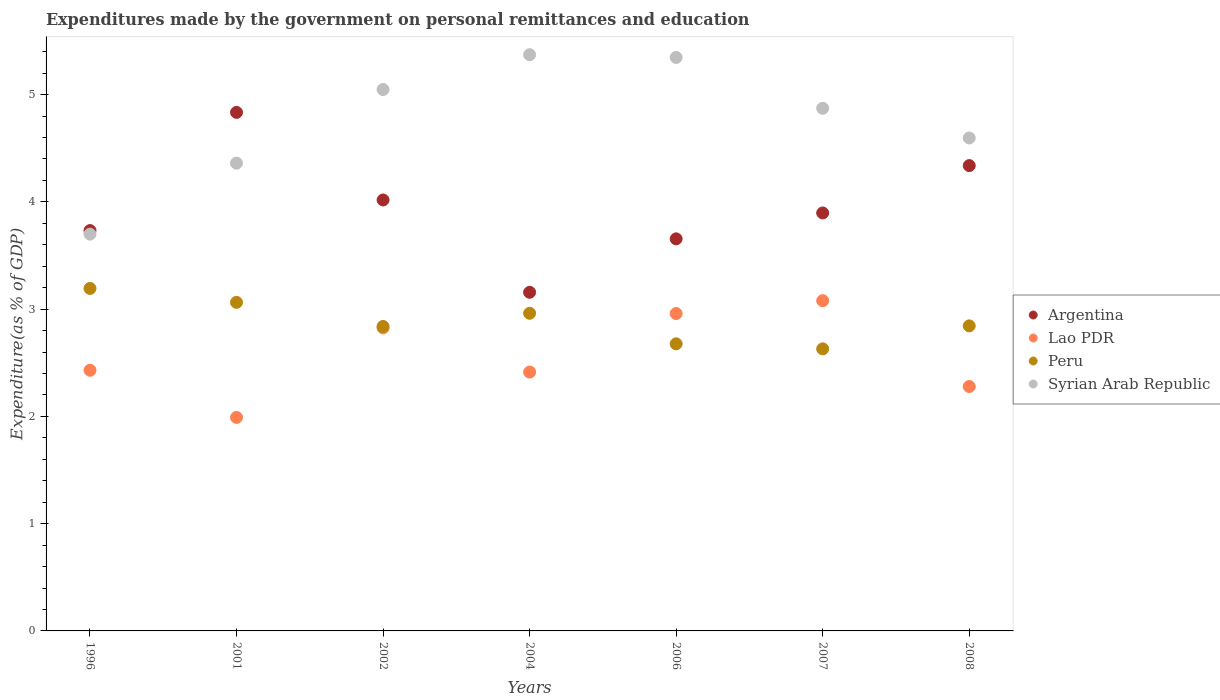What is the expenditures made by the government on personal remittances and education in Peru in 2008?
Your answer should be compact. 2.84. Across all years, what is the maximum expenditures made by the government on personal remittances and education in Syrian Arab Republic?
Provide a succinct answer. 5.37. Across all years, what is the minimum expenditures made by the government on personal remittances and education in Syrian Arab Republic?
Your answer should be compact. 3.7. In which year was the expenditures made by the government on personal remittances and education in Lao PDR maximum?
Provide a succinct answer. 2007. In which year was the expenditures made by the government on personal remittances and education in Argentina minimum?
Offer a very short reply. 2004. What is the total expenditures made by the government on personal remittances and education in Lao PDR in the graph?
Offer a very short reply. 17.97. What is the difference between the expenditures made by the government on personal remittances and education in Lao PDR in 1996 and that in 2008?
Your answer should be compact. 0.15. What is the difference between the expenditures made by the government on personal remittances and education in Peru in 2006 and the expenditures made by the government on personal remittances and education in Argentina in 2002?
Ensure brevity in your answer.  -1.34. What is the average expenditures made by the government on personal remittances and education in Lao PDR per year?
Make the answer very short. 2.57. In the year 2002, what is the difference between the expenditures made by the government on personal remittances and education in Peru and expenditures made by the government on personal remittances and education in Argentina?
Offer a very short reply. -1.18. What is the ratio of the expenditures made by the government on personal remittances and education in Peru in 1996 to that in 2001?
Give a very brief answer. 1.04. Is the difference between the expenditures made by the government on personal remittances and education in Peru in 2001 and 2002 greater than the difference between the expenditures made by the government on personal remittances and education in Argentina in 2001 and 2002?
Provide a short and direct response. No. What is the difference between the highest and the second highest expenditures made by the government on personal remittances and education in Peru?
Your answer should be compact. 0.13. What is the difference between the highest and the lowest expenditures made by the government on personal remittances and education in Syrian Arab Republic?
Your answer should be very brief. 1.67. Is the sum of the expenditures made by the government on personal remittances and education in Syrian Arab Republic in 2001 and 2008 greater than the maximum expenditures made by the government on personal remittances and education in Peru across all years?
Your answer should be very brief. Yes. Is it the case that in every year, the sum of the expenditures made by the government on personal remittances and education in Peru and expenditures made by the government on personal remittances and education in Argentina  is greater than the sum of expenditures made by the government on personal remittances and education in Lao PDR and expenditures made by the government on personal remittances and education in Syrian Arab Republic?
Provide a succinct answer. No. Is the expenditures made by the government on personal remittances and education in Syrian Arab Republic strictly greater than the expenditures made by the government on personal remittances and education in Argentina over the years?
Your answer should be very brief. No. How many years are there in the graph?
Your answer should be compact. 7. What is the difference between two consecutive major ticks on the Y-axis?
Your answer should be compact. 1. Does the graph contain any zero values?
Make the answer very short. No. Where does the legend appear in the graph?
Your answer should be compact. Center right. What is the title of the graph?
Provide a succinct answer. Expenditures made by the government on personal remittances and education. What is the label or title of the X-axis?
Your answer should be compact. Years. What is the label or title of the Y-axis?
Give a very brief answer. Expenditure(as % of GDP). What is the Expenditure(as % of GDP) in Argentina in 1996?
Your response must be concise. 3.73. What is the Expenditure(as % of GDP) in Lao PDR in 1996?
Your answer should be very brief. 2.43. What is the Expenditure(as % of GDP) of Peru in 1996?
Keep it short and to the point. 3.19. What is the Expenditure(as % of GDP) in Syrian Arab Republic in 1996?
Provide a short and direct response. 3.7. What is the Expenditure(as % of GDP) of Argentina in 2001?
Provide a succinct answer. 4.83. What is the Expenditure(as % of GDP) in Lao PDR in 2001?
Provide a short and direct response. 1.99. What is the Expenditure(as % of GDP) of Peru in 2001?
Your answer should be very brief. 3.06. What is the Expenditure(as % of GDP) in Syrian Arab Republic in 2001?
Make the answer very short. 4.36. What is the Expenditure(as % of GDP) in Argentina in 2002?
Keep it short and to the point. 4.02. What is the Expenditure(as % of GDP) of Lao PDR in 2002?
Offer a very short reply. 2.83. What is the Expenditure(as % of GDP) in Peru in 2002?
Make the answer very short. 2.84. What is the Expenditure(as % of GDP) in Syrian Arab Republic in 2002?
Offer a terse response. 5.05. What is the Expenditure(as % of GDP) in Argentina in 2004?
Provide a succinct answer. 3.16. What is the Expenditure(as % of GDP) of Lao PDR in 2004?
Your response must be concise. 2.41. What is the Expenditure(as % of GDP) in Peru in 2004?
Provide a short and direct response. 2.96. What is the Expenditure(as % of GDP) of Syrian Arab Republic in 2004?
Keep it short and to the point. 5.37. What is the Expenditure(as % of GDP) in Argentina in 2006?
Provide a short and direct response. 3.65. What is the Expenditure(as % of GDP) of Lao PDR in 2006?
Keep it short and to the point. 2.96. What is the Expenditure(as % of GDP) in Peru in 2006?
Your answer should be compact. 2.68. What is the Expenditure(as % of GDP) in Syrian Arab Republic in 2006?
Give a very brief answer. 5.35. What is the Expenditure(as % of GDP) of Argentina in 2007?
Keep it short and to the point. 3.9. What is the Expenditure(as % of GDP) of Lao PDR in 2007?
Keep it short and to the point. 3.08. What is the Expenditure(as % of GDP) of Peru in 2007?
Your answer should be compact. 2.63. What is the Expenditure(as % of GDP) in Syrian Arab Republic in 2007?
Your answer should be compact. 4.87. What is the Expenditure(as % of GDP) in Argentina in 2008?
Your answer should be very brief. 4.34. What is the Expenditure(as % of GDP) in Lao PDR in 2008?
Offer a very short reply. 2.28. What is the Expenditure(as % of GDP) in Peru in 2008?
Offer a terse response. 2.84. What is the Expenditure(as % of GDP) in Syrian Arab Republic in 2008?
Ensure brevity in your answer.  4.6. Across all years, what is the maximum Expenditure(as % of GDP) in Argentina?
Provide a short and direct response. 4.83. Across all years, what is the maximum Expenditure(as % of GDP) in Lao PDR?
Offer a terse response. 3.08. Across all years, what is the maximum Expenditure(as % of GDP) of Peru?
Provide a short and direct response. 3.19. Across all years, what is the maximum Expenditure(as % of GDP) in Syrian Arab Republic?
Your response must be concise. 5.37. Across all years, what is the minimum Expenditure(as % of GDP) of Argentina?
Ensure brevity in your answer.  3.16. Across all years, what is the minimum Expenditure(as % of GDP) of Lao PDR?
Your answer should be very brief. 1.99. Across all years, what is the minimum Expenditure(as % of GDP) in Peru?
Your response must be concise. 2.63. Across all years, what is the minimum Expenditure(as % of GDP) of Syrian Arab Republic?
Ensure brevity in your answer.  3.7. What is the total Expenditure(as % of GDP) of Argentina in the graph?
Your answer should be very brief. 27.63. What is the total Expenditure(as % of GDP) of Lao PDR in the graph?
Your response must be concise. 17.97. What is the total Expenditure(as % of GDP) in Peru in the graph?
Your answer should be very brief. 20.2. What is the total Expenditure(as % of GDP) of Syrian Arab Republic in the graph?
Ensure brevity in your answer.  33.29. What is the difference between the Expenditure(as % of GDP) in Argentina in 1996 and that in 2001?
Offer a very short reply. -1.1. What is the difference between the Expenditure(as % of GDP) of Lao PDR in 1996 and that in 2001?
Ensure brevity in your answer.  0.44. What is the difference between the Expenditure(as % of GDP) of Peru in 1996 and that in 2001?
Your answer should be compact. 0.13. What is the difference between the Expenditure(as % of GDP) in Syrian Arab Republic in 1996 and that in 2001?
Provide a succinct answer. -0.66. What is the difference between the Expenditure(as % of GDP) of Argentina in 1996 and that in 2002?
Keep it short and to the point. -0.29. What is the difference between the Expenditure(as % of GDP) of Lao PDR in 1996 and that in 2002?
Provide a succinct answer. -0.4. What is the difference between the Expenditure(as % of GDP) of Peru in 1996 and that in 2002?
Ensure brevity in your answer.  0.35. What is the difference between the Expenditure(as % of GDP) in Syrian Arab Republic in 1996 and that in 2002?
Your answer should be very brief. -1.35. What is the difference between the Expenditure(as % of GDP) in Argentina in 1996 and that in 2004?
Your answer should be very brief. 0.58. What is the difference between the Expenditure(as % of GDP) in Lao PDR in 1996 and that in 2004?
Provide a succinct answer. 0.02. What is the difference between the Expenditure(as % of GDP) of Peru in 1996 and that in 2004?
Your response must be concise. 0.23. What is the difference between the Expenditure(as % of GDP) of Syrian Arab Republic in 1996 and that in 2004?
Your response must be concise. -1.67. What is the difference between the Expenditure(as % of GDP) in Argentina in 1996 and that in 2006?
Provide a succinct answer. 0.08. What is the difference between the Expenditure(as % of GDP) of Lao PDR in 1996 and that in 2006?
Offer a terse response. -0.53. What is the difference between the Expenditure(as % of GDP) of Peru in 1996 and that in 2006?
Provide a short and direct response. 0.52. What is the difference between the Expenditure(as % of GDP) in Syrian Arab Republic in 1996 and that in 2006?
Ensure brevity in your answer.  -1.65. What is the difference between the Expenditure(as % of GDP) in Argentina in 1996 and that in 2007?
Make the answer very short. -0.16. What is the difference between the Expenditure(as % of GDP) of Lao PDR in 1996 and that in 2007?
Provide a succinct answer. -0.65. What is the difference between the Expenditure(as % of GDP) of Peru in 1996 and that in 2007?
Make the answer very short. 0.56. What is the difference between the Expenditure(as % of GDP) in Syrian Arab Republic in 1996 and that in 2007?
Keep it short and to the point. -1.17. What is the difference between the Expenditure(as % of GDP) in Argentina in 1996 and that in 2008?
Provide a succinct answer. -0.61. What is the difference between the Expenditure(as % of GDP) of Lao PDR in 1996 and that in 2008?
Make the answer very short. 0.15. What is the difference between the Expenditure(as % of GDP) of Peru in 1996 and that in 2008?
Offer a terse response. 0.35. What is the difference between the Expenditure(as % of GDP) in Syrian Arab Republic in 1996 and that in 2008?
Provide a short and direct response. -0.9. What is the difference between the Expenditure(as % of GDP) of Argentina in 2001 and that in 2002?
Your answer should be compact. 0.82. What is the difference between the Expenditure(as % of GDP) of Lao PDR in 2001 and that in 2002?
Offer a very short reply. -0.83. What is the difference between the Expenditure(as % of GDP) of Peru in 2001 and that in 2002?
Provide a short and direct response. 0.22. What is the difference between the Expenditure(as % of GDP) in Syrian Arab Republic in 2001 and that in 2002?
Offer a very short reply. -0.69. What is the difference between the Expenditure(as % of GDP) of Argentina in 2001 and that in 2004?
Provide a succinct answer. 1.68. What is the difference between the Expenditure(as % of GDP) of Lao PDR in 2001 and that in 2004?
Offer a very short reply. -0.42. What is the difference between the Expenditure(as % of GDP) in Peru in 2001 and that in 2004?
Ensure brevity in your answer.  0.1. What is the difference between the Expenditure(as % of GDP) in Syrian Arab Republic in 2001 and that in 2004?
Give a very brief answer. -1.01. What is the difference between the Expenditure(as % of GDP) in Argentina in 2001 and that in 2006?
Your response must be concise. 1.18. What is the difference between the Expenditure(as % of GDP) of Lao PDR in 2001 and that in 2006?
Offer a terse response. -0.97. What is the difference between the Expenditure(as % of GDP) of Peru in 2001 and that in 2006?
Offer a very short reply. 0.39. What is the difference between the Expenditure(as % of GDP) in Syrian Arab Republic in 2001 and that in 2006?
Your answer should be very brief. -0.99. What is the difference between the Expenditure(as % of GDP) of Argentina in 2001 and that in 2007?
Provide a succinct answer. 0.94. What is the difference between the Expenditure(as % of GDP) in Lao PDR in 2001 and that in 2007?
Offer a very short reply. -1.09. What is the difference between the Expenditure(as % of GDP) of Peru in 2001 and that in 2007?
Your response must be concise. 0.43. What is the difference between the Expenditure(as % of GDP) of Syrian Arab Republic in 2001 and that in 2007?
Your answer should be very brief. -0.51. What is the difference between the Expenditure(as % of GDP) in Argentina in 2001 and that in 2008?
Offer a terse response. 0.5. What is the difference between the Expenditure(as % of GDP) of Lao PDR in 2001 and that in 2008?
Your response must be concise. -0.29. What is the difference between the Expenditure(as % of GDP) in Peru in 2001 and that in 2008?
Make the answer very short. 0.22. What is the difference between the Expenditure(as % of GDP) in Syrian Arab Republic in 2001 and that in 2008?
Provide a short and direct response. -0.23. What is the difference between the Expenditure(as % of GDP) in Argentina in 2002 and that in 2004?
Provide a short and direct response. 0.86. What is the difference between the Expenditure(as % of GDP) of Lao PDR in 2002 and that in 2004?
Offer a terse response. 0.41. What is the difference between the Expenditure(as % of GDP) in Peru in 2002 and that in 2004?
Make the answer very short. -0.12. What is the difference between the Expenditure(as % of GDP) of Syrian Arab Republic in 2002 and that in 2004?
Make the answer very short. -0.32. What is the difference between the Expenditure(as % of GDP) of Argentina in 2002 and that in 2006?
Your answer should be compact. 0.36. What is the difference between the Expenditure(as % of GDP) of Lao PDR in 2002 and that in 2006?
Ensure brevity in your answer.  -0.13. What is the difference between the Expenditure(as % of GDP) in Peru in 2002 and that in 2006?
Provide a short and direct response. 0.16. What is the difference between the Expenditure(as % of GDP) in Syrian Arab Republic in 2002 and that in 2006?
Give a very brief answer. -0.3. What is the difference between the Expenditure(as % of GDP) in Argentina in 2002 and that in 2007?
Keep it short and to the point. 0.12. What is the difference between the Expenditure(as % of GDP) in Lao PDR in 2002 and that in 2007?
Provide a succinct answer. -0.25. What is the difference between the Expenditure(as % of GDP) in Peru in 2002 and that in 2007?
Provide a succinct answer. 0.21. What is the difference between the Expenditure(as % of GDP) of Syrian Arab Republic in 2002 and that in 2007?
Ensure brevity in your answer.  0.17. What is the difference between the Expenditure(as % of GDP) in Argentina in 2002 and that in 2008?
Your answer should be compact. -0.32. What is the difference between the Expenditure(as % of GDP) of Lao PDR in 2002 and that in 2008?
Make the answer very short. 0.55. What is the difference between the Expenditure(as % of GDP) in Peru in 2002 and that in 2008?
Keep it short and to the point. -0.01. What is the difference between the Expenditure(as % of GDP) of Syrian Arab Republic in 2002 and that in 2008?
Keep it short and to the point. 0.45. What is the difference between the Expenditure(as % of GDP) of Argentina in 2004 and that in 2006?
Provide a short and direct response. -0.5. What is the difference between the Expenditure(as % of GDP) in Lao PDR in 2004 and that in 2006?
Provide a short and direct response. -0.55. What is the difference between the Expenditure(as % of GDP) in Peru in 2004 and that in 2006?
Provide a succinct answer. 0.28. What is the difference between the Expenditure(as % of GDP) in Syrian Arab Republic in 2004 and that in 2006?
Keep it short and to the point. 0.03. What is the difference between the Expenditure(as % of GDP) of Argentina in 2004 and that in 2007?
Keep it short and to the point. -0.74. What is the difference between the Expenditure(as % of GDP) of Lao PDR in 2004 and that in 2007?
Your answer should be very brief. -0.67. What is the difference between the Expenditure(as % of GDP) in Peru in 2004 and that in 2007?
Your answer should be very brief. 0.33. What is the difference between the Expenditure(as % of GDP) of Syrian Arab Republic in 2004 and that in 2007?
Offer a terse response. 0.5. What is the difference between the Expenditure(as % of GDP) in Argentina in 2004 and that in 2008?
Make the answer very short. -1.18. What is the difference between the Expenditure(as % of GDP) in Lao PDR in 2004 and that in 2008?
Provide a succinct answer. 0.13. What is the difference between the Expenditure(as % of GDP) in Peru in 2004 and that in 2008?
Make the answer very short. 0.12. What is the difference between the Expenditure(as % of GDP) in Syrian Arab Republic in 2004 and that in 2008?
Ensure brevity in your answer.  0.78. What is the difference between the Expenditure(as % of GDP) of Argentina in 2006 and that in 2007?
Your answer should be very brief. -0.24. What is the difference between the Expenditure(as % of GDP) of Lao PDR in 2006 and that in 2007?
Give a very brief answer. -0.12. What is the difference between the Expenditure(as % of GDP) of Peru in 2006 and that in 2007?
Keep it short and to the point. 0.05. What is the difference between the Expenditure(as % of GDP) in Syrian Arab Republic in 2006 and that in 2007?
Offer a very short reply. 0.47. What is the difference between the Expenditure(as % of GDP) in Argentina in 2006 and that in 2008?
Your answer should be very brief. -0.68. What is the difference between the Expenditure(as % of GDP) in Lao PDR in 2006 and that in 2008?
Your answer should be very brief. 0.68. What is the difference between the Expenditure(as % of GDP) in Peru in 2006 and that in 2008?
Offer a terse response. -0.17. What is the difference between the Expenditure(as % of GDP) of Syrian Arab Republic in 2006 and that in 2008?
Your answer should be very brief. 0.75. What is the difference between the Expenditure(as % of GDP) in Argentina in 2007 and that in 2008?
Your answer should be very brief. -0.44. What is the difference between the Expenditure(as % of GDP) of Lao PDR in 2007 and that in 2008?
Ensure brevity in your answer.  0.8. What is the difference between the Expenditure(as % of GDP) of Peru in 2007 and that in 2008?
Offer a terse response. -0.21. What is the difference between the Expenditure(as % of GDP) in Syrian Arab Republic in 2007 and that in 2008?
Provide a succinct answer. 0.28. What is the difference between the Expenditure(as % of GDP) of Argentina in 1996 and the Expenditure(as % of GDP) of Lao PDR in 2001?
Keep it short and to the point. 1.74. What is the difference between the Expenditure(as % of GDP) in Argentina in 1996 and the Expenditure(as % of GDP) in Peru in 2001?
Keep it short and to the point. 0.67. What is the difference between the Expenditure(as % of GDP) of Argentina in 1996 and the Expenditure(as % of GDP) of Syrian Arab Republic in 2001?
Your answer should be compact. -0.63. What is the difference between the Expenditure(as % of GDP) in Lao PDR in 1996 and the Expenditure(as % of GDP) in Peru in 2001?
Your answer should be compact. -0.63. What is the difference between the Expenditure(as % of GDP) of Lao PDR in 1996 and the Expenditure(as % of GDP) of Syrian Arab Republic in 2001?
Your answer should be very brief. -1.93. What is the difference between the Expenditure(as % of GDP) in Peru in 1996 and the Expenditure(as % of GDP) in Syrian Arab Republic in 2001?
Ensure brevity in your answer.  -1.17. What is the difference between the Expenditure(as % of GDP) in Argentina in 1996 and the Expenditure(as % of GDP) in Lao PDR in 2002?
Offer a very short reply. 0.91. What is the difference between the Expenditure(as % of GDP) of Argentina in 1996 and the Expenditure(as % of GDP) of Peru in 2002?
Provide a succinct answer. 0.89. What is the difference between the Expenditure(as % of GDP) of Argentina in 1996 and the Expenditure(as % of GDP) of Syrian Arab Republic in 2002?
Your answer should be compact. -1.31. What is the difference between the Expenditure(as % of GDP) of Lao PDR in 1996 and the Expenditure(as % of GDP) of Peru in 2002?
Ensure brevity in your answer.  -0.41. What is the difference between the Expenditure(as % of GDP) of Lao PDR in 1996 and the Expenditure(as % of GDP) of Syrian Arab Republic in 2002?
Ensure brevity in your answer.  -2.62. What is the difference between the Expenditure(as % of GDP) in Peru in 1996 and the Expenditure(as % of GDP) in Syrian Arab Republic in 2002?
Offer a terse response. -1.85. What is the difference between the Expenditure(as % of GDP) in Argentina in 1996 and the Expenditure(as % of GDP) in Lao PDR in 2004?
Keep it short and to the point. 1.32. What is the difference between the Expenditure(as % of GDP) in Argentina in 1996 and the Expenditure(as % of GDP) in Peru in 2004?
Offer a very short reply. 0.77. What is the difference between the Expenditure(as % of GDP) in Argentina in 1996 and the Expenditure(as % of GDP) in Syrian Arab Republic in 2004?
Keep it short and to the point. -1.64. What is the difference between the Expenditure(as % of GDP) in Lao PDR in 1996 and the Expenditure(as % of GDP) in Peru in 2004?
Provide a succinct answer. -0.53. What is the difference between the Expenditure(as % of GDP) of Lao PDR in 1996 and the Expenditure(as % of GDP) of Syrian Arab Republic in 2004?
Your response must be concise. -2.94. What is the difference between the Expenditure(as % of GDP) in Peru in 1996 and the Expenditure(as % of GDP) in Syrian Arab Republic in 2004?
Keep it short and to the point. -2.18. What is the difference between the Expenditure(as % of GDP) in Argentina in 1996 and the Expenditure(as % of GDP) in Lao PDR in 2006?
Give a very brief answer. 0.77. What is the difference between the Expenditure(as % of GDP) in Argentina in 1996 and the Expenditure(as % of GDP) in Peru in 2006?
Give a very brief answer. 1.06. What is the difference between the Expenditure(as % of GDP) in Argentina in 1996 and the Expenditure(as % of GDP) in Syrian Arab Republic in 2006?
Provide a succinct answer. -1.61. What is the difference between the Expenditure(as % of GDP) of Lao PDR in 1996 and the Expenditure(as % of GDP) of Peru in 2006?
Your answer should be compact. -0.25. What is the difference between the Expenditure(as % of GDP) of Lao PDR in 1996 and the Expenditure(as % of GDP) of Syrian Arab Republic in 2006?
Provide a short and direct response. -2.92. What is the difference between the Expenditure(as % of GDP) in Peru in 1996 and the Expenditure(as % of GDP) in Syrian Arab Republic in 2006?
Your answer should be compact. -2.15. What is the difference between the Expenditure(as % of GDP) of Argentina in 1996 and the Expenditure(as % of GDP) of Lao PDR in 2007?
Provide a short and direct response. 0.65. What is the difference between the Expenditure(as % of GDP) of Argentina in 1996 and the Expenditure(as % of GDP) of Peru in 2007?
Offer a very short reply. 1.1. What is the difference between the Expenditure(as % of GDP) in Argentina in 1996 and the Expenditure(as % of GDP) in Syrian Arab Republic in 2007?
Make the answer very short. -1.14. What is the difference between the Expenditure(as % of GDP) of Lao PDR in 1996 and the Expenditure(as % of GDP) of Peru in 2007?
Give a very brief answer. -0.2. What is the difference between the Expenditure(as % of GDP) in Lao PDR in 1996 and the Expenditure(as % of GDP) in Syrian Arab Republic in 2007?
Offer a very short reply. -2.44. What is the difference between the Expenditure(as % of GDP) in Peru in 1996 and the Expenditure(as % of GDP) in Syrian Arab Republic in 2007?
Give a very brief answer. -1.68. What is the difference between the Expenditure(as % of GDP) of Argentina in 1996 and the Expenditure(as % of GDP) of Lao PDR in 2008?
Offer a very short reply. 1.45. What is the difference between the Expenditure(as % of GDP) of Argentina in 1996 and the Expenditure(as % of GDP) of Peru in 2008?
Your response must be concise. 0.89. What is the difference between the Expenditure(as % of GDP) in Argentina in 1996 and the Expenditure(as % of GDP) in Syrian Arab Republic in 2008?
Provide a short and direct response. -0.86. What is the difference between the Expenditure(as % of GDP) in Lao PDR in 1996 and the Expenditure(as % of GDP) in Peru in 2008?
Provide a short and direct response. -0.41. What is the difference between the Expenditure(as % of GDP) of Lao PDR in 1996 and the Expenditure(as % of GDP) of Syrian Arab Republic in 2008?
Provide a succinct answer. -2.17. What is the difference between the Expenditure(as % of GDP) of Peru in 1996 and the Expenditure(as % of GDP) of Syrian Arab Republic in 2008?
Make the answer very short. -1.4. What is the difference between the Expenditure(as % of GDP) of Argentina in 2001 and the Expenditure(as % of GDP) of Lao PDR in 2002?
Provide a succinct answer. 2.01. What is the difference between the Expenditure(as % of GDP) of Argentina in 2001 and the Expenditure(as % of GDP) of Peru in 2002?
Your response must be concise. 2. What is the difference between the Expenditure(as % of GDP) of Argentina in 2001 and the Expenditure(as % of GDP) of Syrian Arab Republic in 2002?
Your answer should be compact. -0.21. What is the difference between the Expenditure(as % of GDP) in Lao PDR in 2001 and the Expenditure(as % of GDP) in Peru in 2002?
Your response must be concise. -0.85. What is the difference between the Expenditure(as % of GDP) in Lao PDR in 2001 and the Expenditure(as % of GDP) in Syrian Arab Republic in 2002?
Your answer should be compact. -3.06. What is the difference between the Expenditure(as % of GDP) in Peru in 2001 and the Expenditure(as % of GDP) in Syrian Arab Republic in 2002?
Your answer should be compact. -1.98. What is the difference between the Expenditure(as % of GDP) of Argentina in 2001 and the Expenditure(as % of GDP) of Lao PDR in 2004?
Your response must be concise. 2.42. What is the difference between the Expenditure(as % of GDP) of Argentina in 2001 and the Expenditure(as % of GDP) of Peru in 2004?
Give a very brief answer. 1.87. What is the difference between the Expenditure(as % of GDP) of Argentina in 2001 and the Expenditure(as % of GDP) of Syrian Arab Republic in 2004?
Offer a terse response. -0.54. What is the difference between the Expenditure(as % of GDP) in Lao PDR in 2001 and the Expenditure(as % of GDP) in Peru in 2004?
Make the answer very short. -0.97. What is the difference between the Expenditure(as % of GDP) in Lao PDR in 2001 and the Expenditure(as % of GDP) in Syrian Arab Republic in 2004?
Give a very brief answer. -3.38. What is the difference between the Expenditure(as % of GDP) in Peru in 2001 and the Expenditure(as % of GDP) in Syrian Arab Republic in 2004?
Provide a succinct answer. -2.31. What is the difference between the Expenditure(as % of GDP) of Argentina in 2001 and the Expenditure(as % of GDP) of Lao PDR in 2006?
Ensure brevity in your answer.  1.88. What is the difference between the Expenditure(as % of GDP) in Argentina in 2001 and the Expenditure(as % of GDP) in Peru in 2006?
Your answer should be very brief. 2.16. What is the difference between the Expenditure(as % of GDP) in Argentina in 2001 and the Expenditure(as % of GDP) in Syrian Arab Republic in 2006?
Offer a terse response. -0.51. What is the difference between the Expenditure(as % of GDP) in Lao PDR in 2001 and the Expenditure(as % of GDP) in Peru in 2006?
Provide a short and direct response. -0.69. What is the difference between the Expenditure(as % of GDP) of Lao PDR in 2001 and the Expenditure(as % of GDP) of Syrian Arab Republic in 2006?
Ensure brevity in your answer.  -3.36. What is the difference between the Expenditure(as % of GDP) in Peru in 2001 and the Expenditure(as % of GDP) in Syrian Arab Republic in 2006?
Ensure brevity in your answer.  -2.28. What is the difference between the Expenditure(as % of GDP) in Argentina in 2001 and the Expenditure(as % of GDP) in Lao PDR in 2007?
Provide a succinct answer. 1.76. What is the difference between the Expenditure(as % of GDP) of Argentina in 2001 and the Expenditure(as % of GDP) of Peru in 2007?
Offer a terse response. 2.2. What is the difference between the Expenditure(as % of GDP) of Argentina in 2001 and the Expenditure(as % of GDP) of Syrian Arab Republic in 2007?
Ensure brevity in your answer.  -0.04. What is the difference between the Expenditure(as % of GDP) in Lao PDR in 2001 and the Expenditure(as % of GDP) in Peru in 2007?
Your answer should be compact. -0.64. What is the difference between the Expenditure(as % of GDP) in Lao PDR in 2001 and the Expenditure(as % of GDP) in Syrian Arab Republic in 2007?
Provide a short and direct response. -2.88. What is the difference between the Expenditure(as % of GDP) in Peru in 2001 and the Expenditure(as % of GDP) in Syrian Arab Republic in 2007?
Ensure brevity in your answer.  -1.81. What is the difference between the Expenditure(as % of GDP) in Argentina in 2001 and the Expenditure(as % of GDP) in Lao PDR in 2008?
Keep it short and to the point. 2.56. What is the difference between the Expenditure(as % of GDP) in Argentina in 2001 and the Expenditure(as % of GDP) in Peru in 2008?
Keep it short and to the point. 1.99. What is the difference between the Expenditure(as % of GDP) of Argentina in 2001 and the Expenditure(as % of GDP) of Syrian Arab Republic in 2008?
Your answer should be compact. 0.24. What is the difference between the Expenditure(as % of GDP) in Lao PDR in 2001 and the Expenditure(as % of GDP) in Peru in 2008?
Ensure brevity in your answer.  -0.85. What is the difference between the Expenditure(as % of GDP) of Lao PDR in 2001 and the Expenditure(as % of GDP) of Syrian Arab Republic in 2008?
Provide a succinct answer. -2.6. What is the difference between the Expenditure(as % of GDP) of Peru in 2001 and the Expenditure(as % of GDP) of Syrian Arab Republic in 2008?
Your answer should be compact. -1.53. What is the difference between the Expenditure(as % of GDP) of Argentina in 2002 and the Expenditure(as % of GDP) of Lao PDR in 2004?
Offer a terse response. 1.6. What is the difference between the Expenditure(as % of GDP) of Argentina in 2002 and the Expenditure(as % of GDP) of Peru in 2004?
Provide a succinct answer. 1.06. What is the difference between the Expenditure(as % of GDP) in Argentina in 2002 and the Expenditure(as % of GDP) in Syrian Arab Republic in 2004?
Your response must be concise. -1.35. What is the difference between the Expenditure(as % of GDP) of Lao PDR in 2002 and the Expenditure(as % of GDP) of Peru in 2004?
Your answer should be very brief. -0.14. What is the difference between the Expenditure(as % of GDP) of Lao PDR in 2002 and the Expenditure(as % of GDP) of Syrian Arab Republic in 2004?
Offer a very short reply. -2.55. What is the difference between the Expenditure(as % of GDP) in Peru in 2002 and the Expenditure(as % of GDP) in Syrian Arab Republic in 2004?
Give a very brief answer. -2.53. What is the difference between the Expenditure(as % of GDP) in Argentina in 2002 and the Expenditure(as % of GDP) in Lao PDR in 2006?
Keep it short and to the point. 1.06. What is the difference between the Expenditure(as % of GDP) in Argentina in 2002 and the Expenditure(as % of GDP) in Peru in 2006?
Your answer should be compact. 1.34. What is the difference between the Expenditure(as % of GDP) of Argentina in 2002 and the Expenditure(as % of GDP) of Syrian Arab Republic in 2006?
Your answer should be very brief. -1.33. What is the difference between the Expenditure(as % of GDP) of Lao PDR in 2002 and the Expenditure(as % of GDP) of Peru in 2006?
Give a very brief answer. 0.15. What is the difference between the Expenditure(as % of GDP) of Lao PDR in 2002 and the Expenditure(as % of GDP) of Syrian Arab Republic in 2006?
Make the answer very short. -2.52. What is the difference between the Expenditure(as % of GDP) of Peru in 2002 and the Expenditure(as % of GDP) of Syrian Arab Republic in 2006?
Provide a short and direct response. -2.51. What is the difference between the Expenditure(as % of GDP) of Argentina in 2002 and the Expenditure(as % of GDP) of Lao PDR in 2007?
Your response must be concise. 0.94. What is the difference between the Expenditure(as % of GDP) of Argentina in 2002 and the Expenditure(as % of GDP) of Peru in 2007?
Offer a terse response. 1.39. What is the difference between the Expenditure(as % of GDP) in Argentina in 2002 and the Expenditure(as % of GDP) in Syrian Arab Republic in 2007?
Your answer should be compact. -0.85. What is the difference between the Expenditure(as % of GDP) of Lao PDR in 2002 and the Expenditure(as % of GDP) of Peru in 2007?
Provide a short and direct response. 0.2. What is the difference between the Expenditure(as % of GDP) of Lao PDR in 2002 and the Expenditure(as % of GDP) of Syrian Arab Republic in 2007?
Ensure brevity in your answer.  -2.05. What is the difference between the Expenditure(as % of GDP) in Peru in 2002 and the Expenditure(as % of GDP) in Syrian Arab Republic in 2007?
Keep it short and to the point. -2.03. What is the difference between the Expenditure(as % of GDP) in Argentina in 2002 and the Expenditure(as % of GDP) in Lao PDR in 2008?
Provide a succinct answer. 1.74. What is the difference between the Expenditure(as % of GDP) in Argentina in 2002 and the Expenditure(as % of GDP) in Peru in 2008?
Your response must be concise. 1.17. What is the difference between the Expenditure(as % of GDP) in Argentina in 2002 and the Expenditure(as % of GDP) in Syrian Arab Republic in 2008?
Ensure brevity in your answer.  -0.58. What is the difference between the Expenditure(as % of GDP) of Lao PDR in 2002 and the Expenditure(as % of GDP) of Peru in 2008?
Keep it short and to the point. -0.02. What is the difference between the Expenditure(as % of GDP) of Lao PDR in 2002 and the Expenditure(as % of GDP) of Syrian Arab Republic in 2008?
Your response must be concise. -1.77. What is the difference between the Expenditure(as % of GDP) in Peru in 2002 and the Expenditure(as % of GDP) in Syrian Arab Republic in 2008?
Ensure brevity in your answer.  -1.76. What is the difference between the Expenditure(as % of GDP) of Argentina in 2004 and the Expenditure(as % of GDP) of Lao PDR in 2006?
Offer a very short reply. 0.2. What is the difference between the Expenditure(as % of GDP) of Argentina in 2004 and the Expenditure(as % of GDP) of Peru in 2006?
Make the answer very short. 0.48. What is the difference between the Expenditure(as % of GDP) in Argentina in 2004 and the Expenditure(as % of GDP) in Syrian Arab Republic in 2006?
Offer a terse response. -2.19. What is the difference between the Expenditure(as % of GDP) in Lao PDR in 2004 and the Expenditure(as % of GDP) in Peru in 2006?
Provide a short and direct response. -0.26. What is the difference between the Expenditure(as % of GDP) in Lao PDR in 2004 and the Expenditure(as % of GDP) in Syrian Arab Republic in 2006?
Your answer should be compact. -2.93. What is the difference between the Expenditure(as % of GDP) of Peru in 2004 and the Expenditure(as % of GDP) of Syrian Arab Republic in 2006?
Ensure brevity in your answer.  -2.38. What is the difference between the Expenditure(as % of GDP) in Argentina in 2004 and the Expenditure(as % of GDP) in Lao PDR in 2007?
Keep it short and to the point. 0.08. What is the difference between the Expenditure(as % of GDP) of Argentina in 2004 and the Expenditure(as % of GDP) of Peru in 2007?
Make the answer very short. 0.53. What is the difference between the Expenditure(as % of GDP) of Argentina in 2004 and the Expenditure(as % of GDP) of Syrian Arab Republic in 2007?
Give a very brief answer. -1.72. What is the difference between the Expenditure(as % of GDP) in Lao PDR in 2004 and the Expenditure(as % of GDP) in Peru in 2007?
Offer a terse response. -0.22. What is the difference between the Expenditure(as % of GDP) in Lao PDR in 2004 and the Expenditure(as % of GDP) in Syrian Arab Republic in 2007?
Your response must be concise. -2.46. What is the difference between the Expenditure(as % of GDP) in Peru in 2004 and the Expenditure(as % of GDP) in Syrian Arab Republic in 2007?
Provide a succinct answer. -1.91. What is the difference between the Expenditure(as % of GDP) of Argentina in 2004 and the Expenditure(as % of GDP) of Lao PDR in 2008?
Offer a terse response. 0.88. What is the difference between the Expenditure(as % of GDP) in Argentina in 2004 and the Expenditure(as % of GDP) in Peru in 2008?
Your answer should be compact. 0.31. What is the difference between the Expenditure(as % of GDP) in Argentina in 2004 and the Expenditure(as % of GDP) in Syrian Arab Republic in 2008?
Your answer should be compact. -1.44. What is the difference between the Expenditure(as % of GDP) in Lao PDR in 2004 and the Expenditure(as % of GDP) in Peru in 2008?
Offer a terse response. -0.43. What is the difference between the Expenditure(as % of GDP) in Lao PDR in 2004 and the Expenditure(as % of GDP) in Syrian Arab Republic in 2008?
Offer a very short reply. -2.18. What is the difference between the Expenditure(as % of GDP) in Peru in 2004 and the Expenditure(as % of GDP) in Syrian Arab Republic in 2008?
Keep it short and to the point. -1.63. What is the difference between the Expenditure(as % of GDP) of Argentina in 2006 and the Expenditure(as % of GDP) of Lao PDR in 2007?
Offer a very short reply. 0.58. What is the difference between the Expenditure(as % of GDP) of Argentina in 2006 and the Expenditure(as % of GDP) of Peru in 2007?
Give a very brief answer. 1.03. What is the difference between the Expenditure(as % of GDP) of Argentina in 2006 and the Expenditure(as % of GDP) of Syrian Arab Republic in 2007?
Offer a terse response. -1.22. What is the difference between the Expenditure(as % of GDP) in Lao PDR in 2006 and the Expenditure(as % of GDP) in Peru in 2007?
Your response must be concise. 0.33. What is the difference between the Expenditure(as % of GDP) of Lao PDR in 2006 and the Expenditure(as % of GDP) of Syrian Arab Republic in 2007?
Ensure brevity in your answer.  -1.91. What is the difference between the Expenditure(as % of GDP) of Peru in 2006 and the Expenditure(as % of GDP) of Syrian Arab Republic in 2007?
Give a very brief answer. -2.2. What is the difference between the Expenditure(as % of GDP) in Argentina in 2006 and the Expenditure(as % of GDP) in Lao PDR in 2008?
Ensure brevity in your answer.  1.38. What is the difference between the Expenditure(as % of GDP) of Argentina in 2006 and the Expenditure(as % of GDP) of Peru in 2008?
Offer a very short reply. 0.81. What is the difference between the Expenditure(as % of GDP) of Argentina in 2006 and the Expenditure(as % of GDP) of Syrian Arab Republic in 2008?
Provide a short and direct response. -0.94. What is the difference between the Expenditure(as % of GDP) of Lao PDR in 2006 and the Expenditure(as % of GDP) of Peru in 2008?
Provide a short and direct response. 0.12. What is the difference between the Expenditure(as % of GDP) in Lao PDR in 2006 and the Expenditure(as % of GDP) in Syrian Arab Republic in 2008?
Your response must be concise. -1.64. What is the difference between the Expenditure(as % of GDP) of Peru in 2006 and the Expenditure(as % of GDP) of Syrian Arab Republic in 2008?
Provide a succinct answer. -1.92. What is the difference between the Expenditure(as % of GDP) in Argentina in 2007 and the Expenditure(as % of GDP) in Lao PDR in 2008?
Keep it short and to the point. 1.62. What is the difference between the Expenditure(as % of GDP) of Argentina in 2007 and the Expenditure(as % of GDP) of Peru in 2008?
Give a very brief answer. 1.05. What is the difference between the Expenditure(as % of GDP) of Argentina in 2007 and the Expenditure(as % of GDP) of Syrian Arab Republic in 2008?
Provide a short and direct response. -0.7. What is the difference between the Expenditure(as % of GDP) in Lao PDR in 2007 and the Expenditure(as % of GDP) in Peru in 2008?
Make the answer very short. 0.23. What is the difference between the Expenditure(as % of GDP) of Lao PDR in 2007 and the Expenditure(as % of GDP) of Syrian Arab Republic in 2008?
Provide a short and direct response. -1.52. What is the difference between the Expenditure(as % of GDP) in Peru in 2007 and the Expenditure(as % of GDP) in Syrian Arab Republic in 2008?
Make the answer very short. -1.97. What is the average Expenditure(as % of GDP) in Argentina per year?
Make the answer very short. 3.95. What is the average Expenditure(as % of GDP) in Lao PDR per year?
Your response must be concise. 2.57. What is the average Expenditure(as % of GDP) of Peru per year?
Keep it short and to the point. 2.89. What is the average Expenditure(as % of GDP) of Syrian Arab Republic per year?
Offer a very short reply. 4.76. In the year 1996, what is the difference between the Expenditure(as % of GDP) in Argentina and Expenditure(as % of GDP) in Lao PDR?
Your answer should be very brief. 1.3. In the year 1996, what is the difference between the Expenditure(as % of GDP) in Argentina and Expenditure(as % of GDP) in Peru?
Offer a terse response. 0.54. In the year 1996, what is the difference between the Expenditure(as % of GDP) in Argentina and Expenditure(as % of GDP) in Syrian Arab Republic?
Your answer should be very brief. 0.03. In the year 1996, what is the difference between the Expenditure(as % of GDP) of Lao PDR and Expenditure(as % of GDP) of Peru?
Give a very brief answer. -0.76. In the year 1996, what is the difference between the Expenditure(as % of GDP) of Lao PDR and Expenditure(as % of GDP) of Syrian Arab Republic?
Offer a very short reply. -1.27. In the year 1996, what is the difference between the Expenditure(as % of GDP) of Peru and Expenditure(as % of GDP) of Syrian Arab Republic?
Provide a succinct answer. -0.51. In the year 2001, what is the difference between the Expenditure(as % of GDP) of Argentina and Expenditure(as % of GDP) of Lao PDR?
Offer a very short reply. 2.84. In the year 2001, what is the difference between the Expenditure(as % of GDP) of Argentina and Expenditure(as % of GDP) of Peru?
Your answer should be compact. 1.77. In the year 2001, what is the difference between the Expenditure(as % of GDP) of Argentina and Expenditure(as % of GDP) of Syrian Arab Republic?
Make the answer very short. 0.47. In the year 2001, what is the difference between the Expenditure(as % of GDP) of Lao PDR and Expenditure(as % of GDP) of Peru?
Your answer should be very brief. -1.07. In the year 2001, what is the difference between the Expenditure(as % of GDP) of Lao PDR and Expenditure(as % of GDP) of Syrian Arab Republic?
Offer a terse response. -2.37. In the year 2001, what is the difference between the Expenditure(as % of GDP) of Peru and Expenditure(as % of GDP) of Syrian Arab Republic?
Keep it short and to the point. -1.3. In the year 2002, what is the difference between the Expenditure(as % of GDP) of Argentina and Expenditure(as % of GDP) of Lao PDR?
Your response must be concise. 1.19. In the year 2002, what is the difference between the Expenditure(as % of GDP) in Argentina and Expenditure(as % of GDP) in Peru?
Ensure brevity in your answer.  1.18. In the year 2002, what is the difference between the Expenditure(as % of GDP) of Argentina and Expenditure(as % of GDP) of Syrian Arab Republic?
Make the answer very short. -1.03. In the year 2002, what is the difference between the Expenditure(as % of GDP) of Lao PDR and Expenditure(as % of GDP) of Peru?
Ensure brevity in your answer.  -0.01. In the year 2002, what is the difference between the Expenditure(as % of GDP) of Lao PDR and Expenditure(as % of GDP) of Syrian Arab Republic?
Provide a succinct answer. -2.22. In the year 2002, what is the difference between the Expenditure(as % of GDP) of Peru and Expenditure(as % of GDP) of Syrian Arab Republic?
Ensure brevity in your answer.  -2.21. In the year 2004, what is the difference between the Expenditure(as % of GDP) in Argentina and Expenditure(as % of GDP) in Lao PDR?
Your answer should be very brief. 0.74. In the year 2004, what is the difference between the Expenditure(as % of GDP) in Argentina and Expenditure(as % of GDP) in Peru?
Ensure brevity in your answer.  0.2. In the year 2004, what is the difference between the Expenditure(as % of GDP) in Argentina and Expenditure(as % of GDP) in Syrian Arab Republic?
Give a very brief answer. -2.21. In the year 2004, what is the difference between the Expenditure(as % of GDP) of Lao PDR and Expenditure(as % of GDP) of Peru?
Provide a short and direct response. -0.55. In the year 2004, what is the difference between the Expenditure(as % of GDP) in Lao PDR and Expenditure(as % of GDP) in Syrian Arab Republic?
Ensure brevity in your answer.  -2.96. In the year 2004, what is the difference between the Expenditure(as % of GDP) of Peru and Expenditure(as % of GDP) of Syrian Arab Republic?
Provide a succinct answer. -2.41. In the year 2006, what is the difference between the Expenditure(as % of GDP) of Argentina and Expenditure(as % of GDP) of Lao PDR?
Your answer should be compact. 0.7. In the year 2006, what is the difference between the Expenditure(as % of GDP) in Argentina and Expenditure(as % of GDP) in Peru?
Keep it short and to the point. 0.98. In the year 2006, what is the difference between the Expenditure(as % of GDP) of Argentina and Expenditure(as % of GDP) of Syrian Arab Republic?
Provide a short and direct response. -1.69. In the year 2006, what is the difference between the Expenditure(as % of GDP) of Lao PDR and Expenditure(as % of GDP) of Peru?
Offer a very short reply. 0.28. In the year 2006, what is the difference between the Expenditure(as % of GDP) of Lao PDR and Expenditure(as % of GDP) of Syrian Arab Republic?
Ensure brevity in your answer.  -2.39. In the year 2006, what is the difference between the Expenditure(as % of GDP) in Peru and Expenditure(as % of GDP) in Syrian Arab Republic?
Provide a succinct answer. -2.67. In the year 2007, what is the difference between the Expenditure(as % of GDP) of Argentina and Expenditure(as % of GDP) of Lao PDR?
Your answer should be very brief. 0.82. In the year 2007, what is the difference between the Expenditure(as % of GDP) in Argentina and Expenditure(as % of GDP) in Peru?
Keep it short and to the point. 1.27. In the year 2007, what is the difference between the Expenditure(as % of GDP) in Argentina and Expenditure(as % of GDP) in Syrian Arab Republic?
Your answer should be very brief. -0.98. In the year 2007, what is the difference between the Expenditure(as % of GDP) in Lao PDR and Expenditure(as % of GDP) in Peru?
Keep it short and to the point. 0.45. In the year 2007, what is the difference between the Expenditure(as % of GDP) of Lao PDR and Expenditure(as % of GDP) of Syrian Arab Republic?
Give a very brief answer. -1.79. In the year 2007, what is the difference between the Expenditure(as % of GDP) in Peru and Expenditure(as % of GDP) in Syrian Arab Republic?
Make the answer very short. -2.24. In the year 2008, what is the difference between the Expenditure(as % of GDP) in Argentina and Expenditure(as % of GDP) in Lao PDR?
Offer a terse response. 2.06. In the year 2008, what is the difference between the Expenditure(as % of GDP) of Argentina and Expenditure(as % of GDP) of Peru?
Give a very brief answer. 1.49. In the year 2008, what is the difference between the Expenditure(as % of GDP) of Argentina and Expenditure(as % of GDP) of Syrian Arab Republic?
Ensure brevity in your answer.  -0.26. In the year 2008, what is the difference between the Expenditure(as % of GDP) of Lao PDR and Expenditure(as % of GDP) of Peru?
Give a very brief answer. -0.57. In the year 2008, what is the difference between the Expenditure(as % of GDP) of Lao PDR and Expenditure(as % of GDP) of Syrian Arab Republic?
Your answer should be very brief. -2.32. In the year 2008, what is the difference between the Expenditure(as % of GDP) in Peru and Expenditure(as % of GDP) in Syrian Arab Republic?
Offer a terse response. -1.75. What is the ratio of the Expenditure(as % of GDP) in Argentina in 1996 to that in 2001?
Give a very brief answer. 0.77. What is the ratio of the Expenditure(as % of GDP) of Lao PDR in 1996 to that in 2001?
Give a very brief answer. 1.22. What is the ratio of the Expenditure(as % of GDP) of Peru in 1996 to that in 2001?
Provide a short and direct response. 1.04. What is the ratio of the Expenditure(as % of GDP) of Syrian Arab Republic in 1996 to that in 2001?
Provide a short and direct response. 0.85. What is the ratio of the Expenditure(as % of GDP) in Argentina in 1996 to that in 2002?
Provide a succinct answer. 0.93. What is the ratio of the Expenditure(as % of GDP) in Lao PDR in 1996 to that in 2002?
Ensure brevity in your answer.  0.86. What is the ratio of the Expenditure(as % of GDP) of Peru in 1996 to that in 2002?
Your response must be concise. 1.12. What is the ratio of the Expenditure(as % of GDP) of Syrian Arab Republic in 1996 to that in 2002?
Give a very brief answer. 0.73. What is the ratio of the Expenditure(as % of GDP) in Argentina in 1996 to that in 2004?
Ensure brevity in your answer.  1.18. What is the ratio of the Expenditure(as % of GDP) of Peru in 1996 to that in 2004?
Make the answer very short. 1.08. What is the ratio of the Expenditure(as % of GDP) in Syrian Arab Republic in 1996 to that in 2004?
Your response must be concise. 0.69. What is the ratio of the Expenditure(as % of GDP) of Argentina in 1996 to that in 2006?
Your answer should be compact. 1.02. What is the ratio of the Expenditure(as % of GDP) of Lao PDR in 1996 to that in 2006?
Provide a short and direct response. 0.82. What is the ratio of the Expenditure(as % of GDP) in Peru in 1996 to that in 2006?
Provide a short and direct response. 1.19. What is the ratio of the Expenditure(as % of GDP) in Syrian Arab Republic in 1996 to that in 2006?
Ensure brevity in your answer.  0.69. What is the ratio of the Expenditure(as % of GDP) of Argentina in 1996 to that in 2007?
Offer a terse response. 0.96. What is the ratio of the Expenditure(as % of GDP) of Lao PDR in 1996 to that in 2007?
Give a very brief answer. 0.79. What is the ratio of the Expenditure(as % of GDP) in Peru in 1996 to that in 2007?
Make the answer very short. 1.21. What is the ratio of the Expenditure(as % of GDP) in Syrian Arab Republic in 1996 to that in 2007?
Provide a short and direct response. 0.76. What is the ratio of the Expenditure(as % of GDP) of Argentina in 1996 to that in 2008?
Offer a very short reply. 0.86. What is the ratio of the Expenditure(as % of GDP) in Lao PDR in 1996 to that in 2008?
Your answer should be compact. 1.07. What is the ratio of the Expenditure(as % of GDP) of Peru in 1996 to that in 2008?
Ensure brevity in your answer.  1.12. What is the ratio of the Expenditure(as % of GDP) in Syrian Arab Republic in 1996 to that in 2008?
Offer a terse response. 0.81. What is the ratio of the Expenditure(as % of GDP) of Argentina in 2001 to that in 2002?
Your answer should be very brief. 1.2. What is the ratio of the Expenditure(as % of GDP) of Lao PDR in 2001 to that in 2002?
Your answer should be compact. 0.7. What is the ratio of the Expenditure(as % of GDP) of Peru in 2001 to that in 2002?
Your answer should be very brief. 1.08. What is the ratio of the Expenditure(as % of GDP) of Syrian Arab Republic in 2001 to that in 2002?
Give a very brief answer. 0.86. What is the ratio of the Expenditure(as % of GDP) of Argentina in 2001 to that in 2004?
Give a very brief answer. 1.53. What is the ratio of the Expenditure(as % of GDP) in Lao PDR in 2001 to that in 2004?
Provide a short and direct response. 0.82. What is the ratio of the Expenditure(as % of GDP) in Peru in 2001 to that in 2004?
Your answer should be very brief. 1.03. What is the ratio of the Expenditure(as % of GDP) of Syrian Arab Republic in 2001 to that in 2004?
Provide a short and direct response. 0.81. What is the ratio of the Expenditure(as % of GDP) in Argentina in 2001 to that in 2006?
Provide a succinct answer. 1.32. What is the ratio of the Expenditure(as % of GDP) of Lao PDR in 2001 to that in 2006?
Your answer should be very brief. 0.67. What is the ratio of the Expenditure(as % of GDP) of Peru in 2001 to that in 2006?
Ensure brevity in your answer.  1.14. What is the ratio of the Expenditure(as % of GDP) in Syrian Arab Republic in 2001 to that in 2006?
Ensure brevity in your answer.  0.82. What is the ratio of the Expenditure(as % of GDP) of Argentina in 2001 to that in 2007?
Offer a very short reply. 1.24. What is the ratio of the Expenditure(as % of GDP) of Lao PDR in 2001 to that in 2007?
Offer a very short reply. 0.65. What is the ratio of the Expenditure(as % of GDP) of Peru in 2001 to that in 2007?
Your answer should be very brief. 1.16. What is the ratio of the Expenditure(as % of GDP) in Syrian Arab Republic in 2001 to that in 2007?
Provide a succinct answer. 0.9. What is the ratio of the Expenditure(as % of GDP) of Argentina in 2001 to that in 2008?
Keep it short and to the point. 1.11. What is the ratio of the Expenditure(as % of GDP) of Lao PDR in 2001 to that in 2008?
Provide a short and direct response. 0.87. What is the ratio of the Expenditure(as % of GDP) in Peru in 2001 to that in 2008?
Your response must be concise. 1.08. What is the ratio of the Expenditure(as % of GDP) in Syrian Arab Republic in 2001 to that in 2008?
Keep it short and to the point. 0.95. What is the ratio of the Expenditure(as % of GDP) of Argentina in 2002 to that in 2004?
Keep it short and to the point. 1.27. What is the ratio of the Expenditure(as % of GDP) of Lao PDR in 2002 to that in 2004?
Your answer should be compact. 1.17. What is the ratio of the Expenditure(as % of GDP) in Peru in 2002 to that in 2004?
Make the answer very short. 0.96. What is the ratio of the Expenditure(as % of GDP) of Syrian Arab Republic in 2002 to that in 2004?
Your answer should be very brief. 0.94. What is the ratio of the Expenditure(as % of GDP) in Argentina in 2002 to that in 2006?
Provide a succinct answer. 1.1. What is the ratio of the Expenditure(as % of GDP) in Lao PDR in 2002 to that in 2006?
Your answer should be very brief. 0.95. What is the ratio of the Expenditure(as % of GDP) of Peru in 2002 to that in 2006?
Make the answer very short. 1.06. What is the ratio of the Expenditure(as % of GDP) in Syrian Arab Republic in 2002 to that in 2006?
Give a very brief answer. 0.94. What is the ratio of the Expenditure(as % of GDP) in Argentina in 2002 to that in 2007?
Offer a terse response. 1.03. What is the ratio of the Expenditure(as % of GDP) in Lao PDR in 2002 to that in 2007?
Give a very brief answer. 0.92. What is the ratio of the Expenditure(as % of GDP) of Peru in 2002 to that in 2007?
Provide a succinct answer. 1.08. What is the ratio of the Expenditure(as % of GDP) of Syrian Arab Republic in 2002 to that in 2007?
Give a very brief answer. 1.04. What is the ratio of the Expenditure(as % of GDP) of Argentina in 2002 to that in 2008?
Your answer should be very brief. 0.93. What is the ratio of the Expenditure(as % of GDP) in Lao PDR in 2002 to that in 2008?
Offer a terse response. 1.24. What is the ratio of the Expenditure(as % of GDP) of Syrian Arab Republic in 2002 to that in 2008?
Your answer should be very brief. 1.1. What is the ratio of the Expenditure(as % of GDP) in Argentina in 2004 to that in 2006?
Your answer should be very brief. 0.86. What is the ratio of the Expenditure(as % of GDP) in Lao PDR in 2004 to that in 2006?
Ensure brevity in your answer.  0.82. What is the ratio of the Expenditure(as % of GDP) of Peru in 2004 to that in 2006?
Keep it short and to the point. 1.11. What is the ratio of the Expenditure(as % of GDP) of Argentina in 2004 to that in 2007?
Your answer should be compact. 0.81. What is the ratio of the Expenditure(as % of GDP) of Lao PDR in 2004 to that in 2007?
Provide a succinct answer. 0.78. What is the ratio of the Expenditure(as % of GDP) in Peru in 2004 to that in 2007?
Provide a succinct answer. 1.13. What is the ratio of the Expenditure(as % of GDP) in Syrian Arab Republic in 2004 to that in 2007?
Offer a very short reply. 1.1. What is the ratio of the Expenditure(as % of GDP) in Argentina in 2004 to that in 2008?
Give a very brief answer. 0.73. What is the ratio of the Expenditure(as % of GDP) in Lao PDR in 2004 to that in 2008?
Provide a succinct answer. 1.06. What is the ratio of the Expenditure(as % of GDP) in Peru in 2004 to that in 2008?
Give a very brief answer. 1.04. What is the ratio of the Expenditure(as % of GDP) of Syrian Arab Republic in 2004 to that in 2008?
Ensure brevity in your answer.  1.17. What is the ratio of the Expenditure(as % of GDP) in Argentina in 2006 to that in 2007?
Your answer should be compact. 0.94. What is the ratio of the Expenditure(as % of GDP) in Lao PDR in 2006 to that in 2007?
Your answer should be very brief. 0.96. What is the ratio of the Expenditure(as % of GDP) in Peru in 2006 to that in 2007?
Give a very brief answer. 1.02. What is the ratio of the Expenditure(as % of GDP) in Syrian Arab Republic in 2006 to that in 2007?
Make the answer very short. 1.1. What is the ratio of the Expenditure(as % of GDP) of Argentina in 2006 to that in 2008?
Your answer should be very brief. 0.84. What is the ratio of the Expenditure(as % of GDP) in Lao PDR in 2006 to that in 2008?
Provide a succinct answer. 1.3. What is the ratio of the Expenditure(as % of GDP) of Syrian Arab Republic in 2006 to that in 2008?
Provide a short and direct response. 1.16. What is the ratio of the Expenditure(as % of GDP) of Argentina in 2007 to that in 2008?
Make the answer very short. 0.9. What is the ratio of the Expenditure(as % of GDP) of Lao PDR in 2007 to that in 2008?
Keep it short and to the point. 1.35. What is the ratio of the Expenditure(as % of GDP) in Peru in 2007 to that in 2008?
Provide a succinct answer. 0.92. What is the ratio of the Expenditure(as % of GDP) in Syrian Arab Republic in 2007 to that in 2008?
Provide a succinct answer. 1.06. What is the difference between the highest and the second highest Expenditure(as % of GDP) in Argentina?
Provide a succinct answer. 0.5. What is the difference between the highest and the second highest Expenditure(as % of GDP) in Lao PDR?
Offer a very short reply. 0.12. What is the difference between the highest and the second highest Expenditure(as % of GDP) of Peru?
Your answer should be very brief. 0.13. What is the difference between the highest and the second highest Expenditure(as % of GDP) in Syrian Arab Republic?
Provide a succinct answer. 0.03. What is the difference between the highest and the lowest Expenditure(as % of GDP) in Argentina?
Your answer should be compact. 1.68. What is the difference between the highest and the lowest Expenditure(as % of GDP) of Lao PDR?
Provide a succinct answer. 1.09. What is the difference between the highest and the lowest Expenditure(as % of GDP) of Peru?
Provide a short and direct response. 0.56. What is the difference between the highest and the lowest Expenditure(as % of GDP) of Syrian Arab Republic?
Provide a succinct answer. 1.67. 